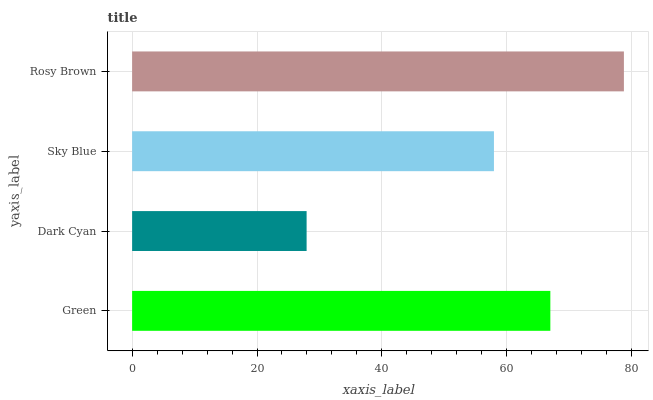Is Dark Cyan the minimum?
Answer yes or no. Yes. Is Rosy Brown the maximum?
Answer yes or no. Yes. Is Sky Blue the minimum?
Answer yes or no. No. Is Sky Blue the maximum?
Answer yes or no. No. Is Sky Blue greater than Dark Cyan?
Answer yes or no. Yes. Is Dark Cyan less than Sky Blue?
Answer yes or no. Yes. Is Dark Cyan greater than Sky Blue?
Answer yes or no. No. Is Sky Blue less than Dark Cyan?
Answer yes or no. No. Is Green the high median?
Answer yes or no. Yes. Is Sky Blue the low median?
Answer yes or no. Yes. Is Dark Cyan the high median?
Answer yes or no. No. Is Rosy Brown the low median?
Answer yes or no. No. 